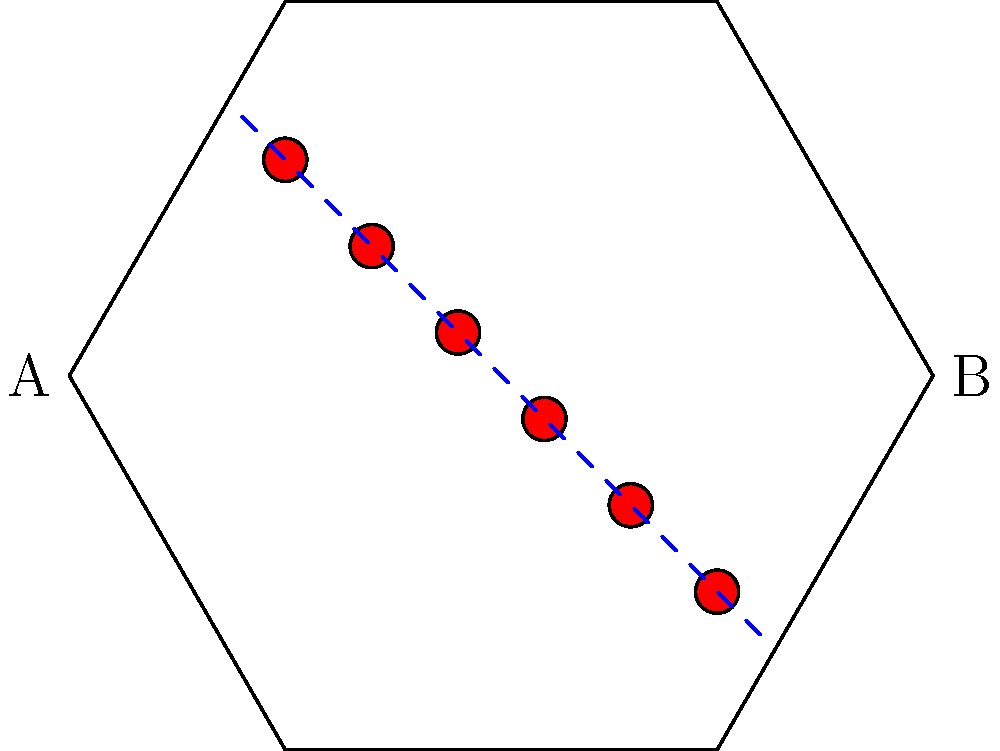In the floor plan of a crime scene shown above, blood spatter drops are represented by red circles. Based on the linear pattern of the blood drops, what can you conclude about the direction of force that caused the spatter, and where would you place the point of origin (A or B)? To analyze the blood spatter pattern and determine the direction of force and point of origin, follow these steps:

1. Observe the pattern: The blood drops form a linear pattern from the top left to the bottom right of the room.

2. Analyze drop shape (implied): In actual blood spatter analysis, elongated drops point in the direction of travel. Here, we assume this principle applies.

3. Determine directionality: The pattern suggests movement from the top left (near point A) towards the bottom right (near point B).

4. Consider the physics: Blood travels in a parabolic arc when projected from a source. The smaller drops typically travel further than larger ones due to air resistance.

5. Identify the point of origin: Given the direction of travel and the principle that smaller drops travel further, the point of origin is likely closer to point A.

6. Confirm with line of travel: The dashed blue line represents the general direction of travel, supporting the conclusion that the force came from near point A towards point B.

Therefore, the direction of force was from A to B, with the point of origin closer to A.
Answer: Direction: A to B; Origin: Near A 